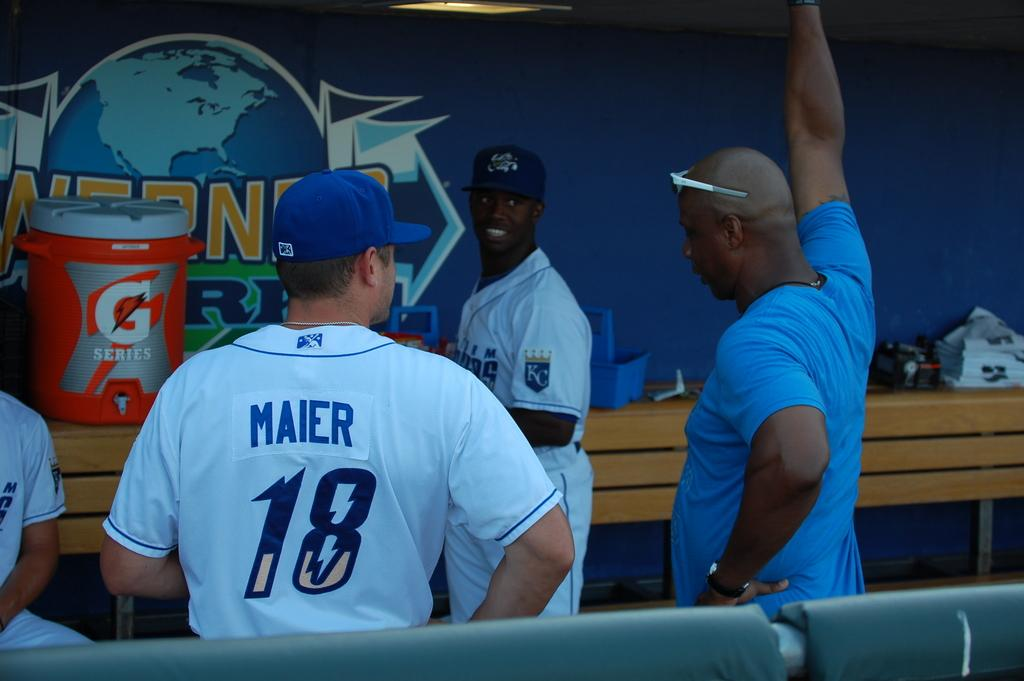<image>
Give a short and clear explanation of the subsequent image. Baseball players talking to each other in the dugout area of a baseball field. 